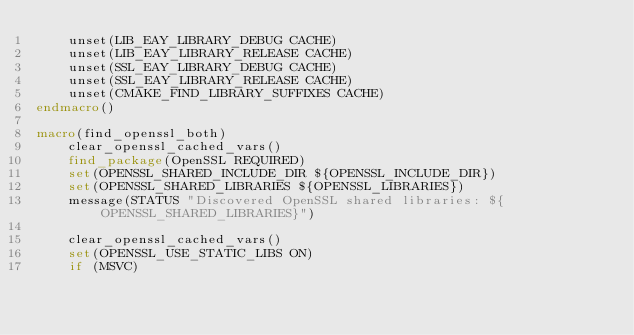<code> <loc_0><loc_0><loc_500><loc_500><_CMake_>    unset(LIB_EAY_LIBRARY_DEBUG CACHE)
    unset(LIB_EAY_LIBRARY_RELEASE CACHE)
    unset(SSL_EAY_LIBRARY_DEBUG CACHE)
    unset(SSL_EAY_LIBRARY_RELEASE CACHE)
    unset(CMAKE_FIND_LIBRARY_SUFFIXES CACHE)
endmacro()

macro(find_openssl_both)
    clear_openssl_cached_vars()
    find_package(OpenSSL REQUIRED)
    set(OPENSSL_SHARED_INCLUDE_DIR ${OPENSSL_INCLUDE_DIR})
    set(OPENSSL_SHARED_LIBRARIES ${OPENSSL_LIBRARIES})
    message(STATUS "Discovered OpenSSL shared libraries: ${OPENSSL_SHARED_LIBRARIES}")

    clear_openssl_cached_vars()
    set(OPENSSL_USE_STATIC_LIBS ON)
    if (MSVC)</code> 